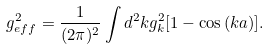<formula> <loc_0><loc_0><loc_500><loc_500>g _ { e f f } ^ { 2 } = \frac { 1 } { ( 2 \pi ) ^ { 2 } } \int d ^ { 2 } k g _ { k } ^ { 2 } [ 1 - \cos { ( } k a { ) } ] .</formula> 